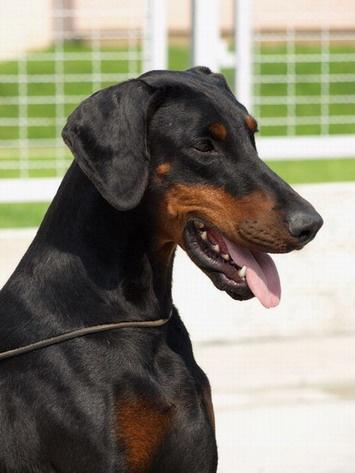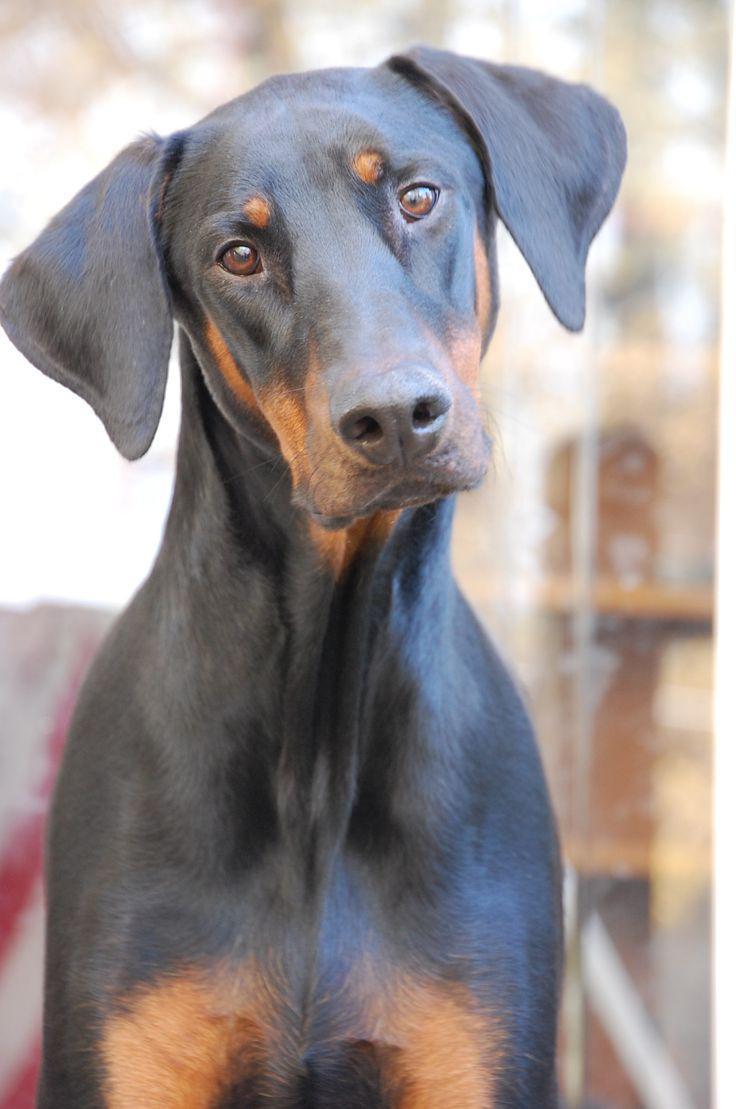The first image is the image on the left, the second image is the image on the right. Evaluate the accuracy of this statement regarding the images: "One of the dogs is looking directly at the camera, and one of the dogs has an open mouth.". Is it true? Answer yes or no. Yes. The first image is the image on the left, the second image is the image on the right. Considering the images on both sides, is "In at least one image there is a black and brown puppy with a heart tag on his collar, laying down." valid? Answer yes or no. No. 